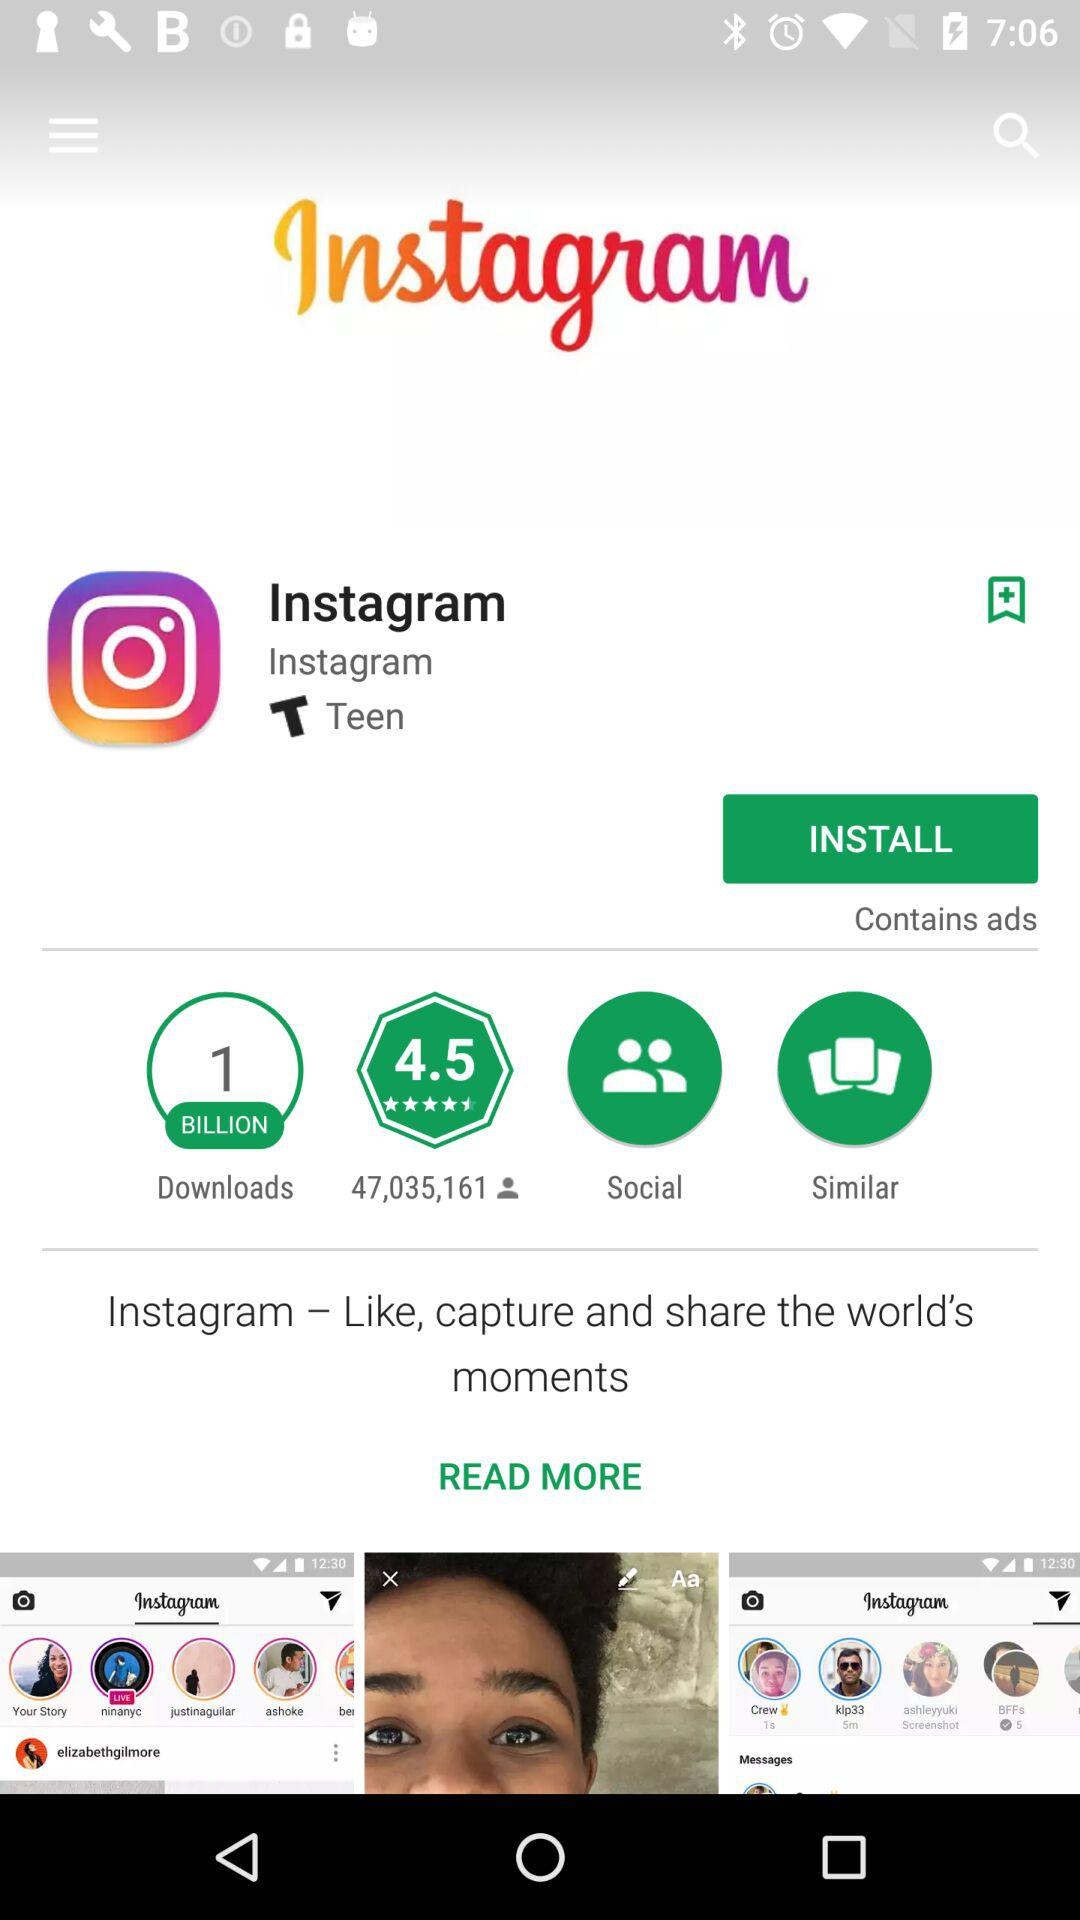What age group is the application targeted at, according to the details provided? The application is categorized under the 'Teen' age group, indicating its content and features are specifically designed to captivate and cater to teenagers. 